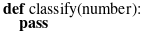Convert code to text. <code><loc_0><loc_0><loc_500><loc_500><_Python_>def classify(number):
    pass
</code> 